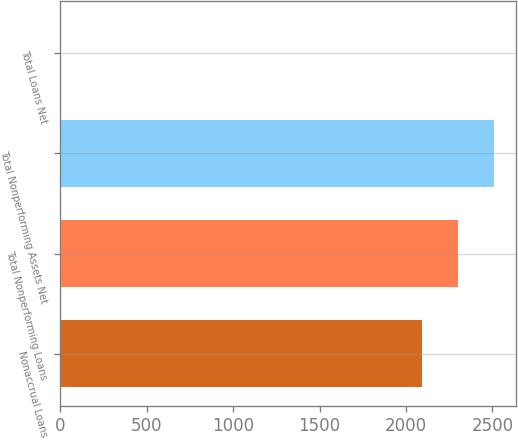Convert chart to OTSL. <chart><loc_0><loc_0><loc_500><loc_500><bar_chart><fcel>Nonaccrual Loans<fcel>Total Nonperforming Loans<fcel>Total Nonperforming Assets Net<fcel>Total Loans Net<nl><fcel>2091<fcel>2300.09<fcel>2509.18<fcel>0.09<nl></chart> 